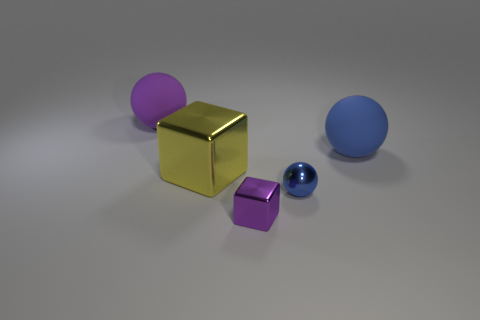Subtract all blue balls. How many balls are left? 1 Subtract all small balls. How many balls are left? 2 Subtract 1 blocks. How many blocks are left? 1 Subtract all blue cubes. How many red balls are left? 0 Add 2 tiny shiny spheres. How many tiny shiny spheres are left? 3 Add 2 big blue objects. How many big blue objects exist? 3 Add 1 small metal objects. How many objects exist? 6 Subtract 0 blue cubes. How many objects are left? 5 Subtract all cubes. How many objects are left? 3 Subtract all red balls. Subtract all purple cylinders. How many balls are left? 3 